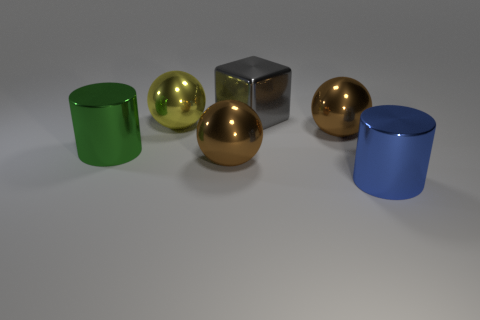What material is the other large object that is the same shape as the blue object?
Ensure brevity in your answer.  Metal. What number of rubber things are big green objects or large objects?
Offer a terse response. 0. Are the large cylinder on the left side of the blue shiny object and the large cylinder in front of the big green metallic thing made of the same material?
Offer a terse response. Yes. Is there a large cyan cube?
Ensure brevity in your answer.  No. Does the yellow shiny object in front of the big shiny block have the same shape as the big brown metal thing that is in front of the green cylinder?
Provide a succinct answer. Yes. Is there a blue thing that has the same material as the big gray cube?
Make the answer very short. Yes. Do the cylinder that is right of the yellow metal thing and the large yellow sphere have the same material?
Your answer should be very brief. Yes. Is the number of brown metallic balls behind the big blue metallic cylinder greater than the number of yellow metal things to the right of the block?
Offer a very short reply. Yes. What color is the metal cube that is the same size as the green shiny cylinder?
Offer a very short reply. Gray. Is the color of the big sphere to the right of the large gray shiny block the same as the ball that is in front of the large green metallic cylinder?
Your answer should be very brief. Yes. 